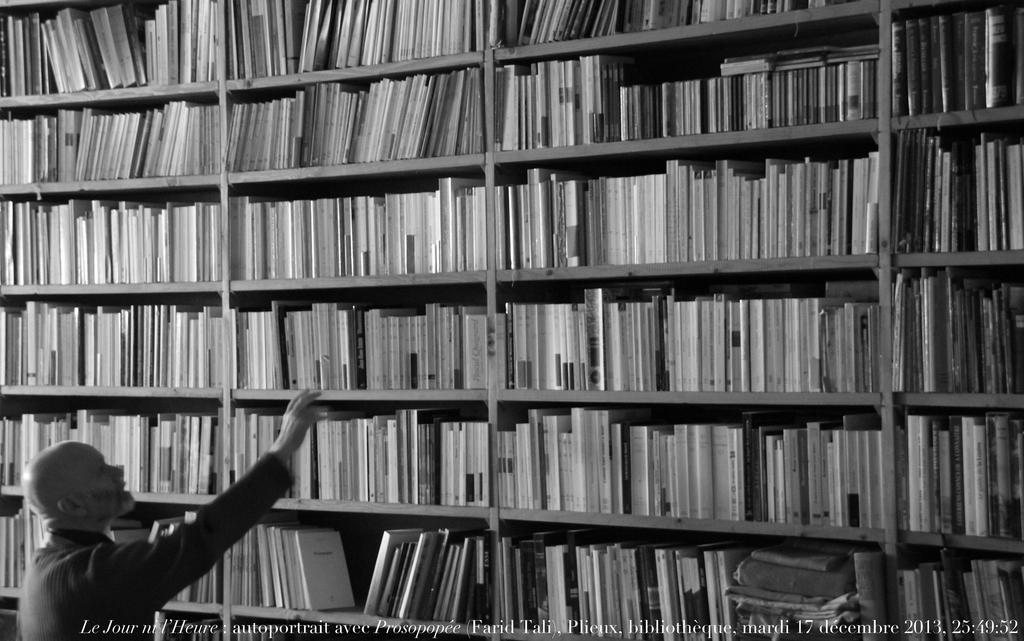What is the color scheme of the image? The image is black and white. Can you describe the person in the image? There is a man standing in the image. What can be seen in the background of the image? There are many books arranged in rows in the image. How many rocks can be seen in the image? There are no rocks present in the image; it features a man standing in front of rows of books. What type of salt is being used to season the books in the image? There is no salt or seasoning present in the image; it only shows a man and rows of books. 